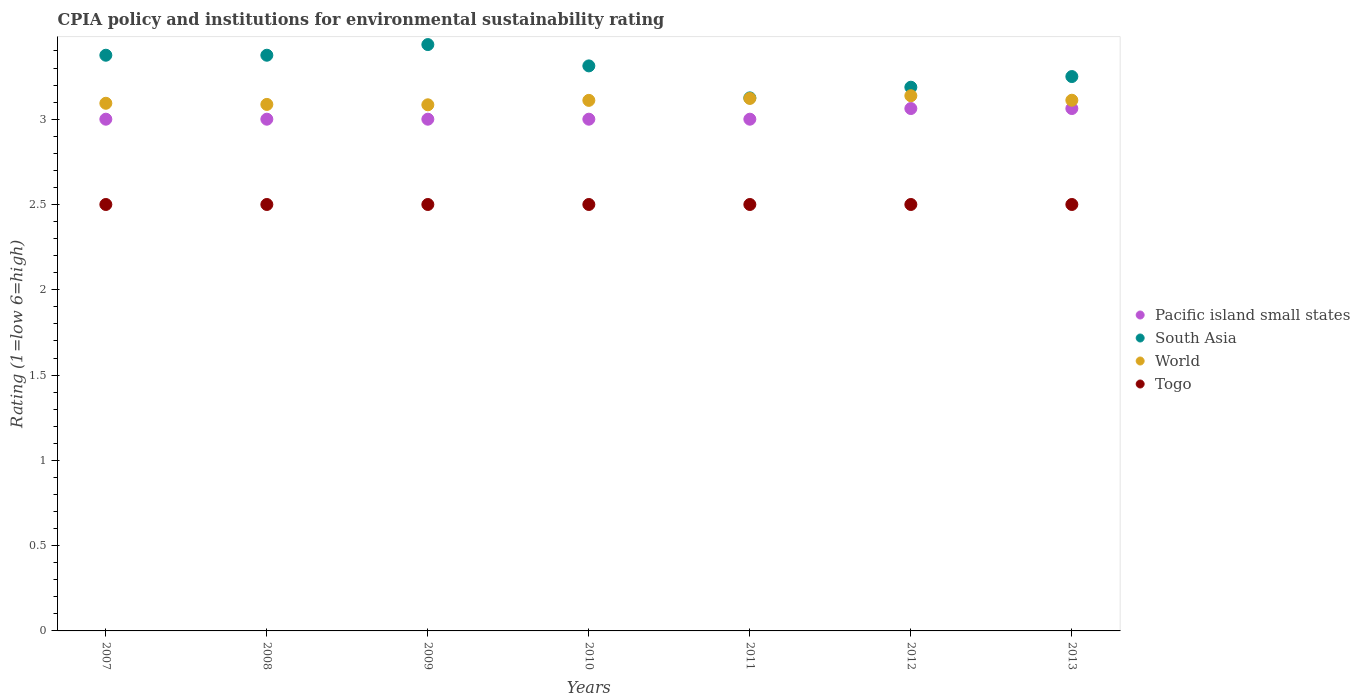What is the CPIA rating in Pacific island small states in 2007?
Ensure brevity in your answer.  3. Across all years, what is the maximum CPIA rating in World?
Offer a terse response. 3.14. Across all years, what is the minimum CPIA rating in South Asia?
Your response must be concise. 3.12. In which year was the CPIA rating in Togo minimum?
Keep it short and to the point. 2007. What is the total CPIA rating in Pacific island small states in the graph?
Keep it short and to the point. 21.12. What is the difference between the CPIA rating in World in 2008 and that in 2009?
Your answer should be very brief. 0. What is the difference between the CPIA rating in Pacific island small states in 2011 and the CPIA rating in South Asia in 2012?
Your answer should be compact. -0.19. What is the average CPIA rating in World per year?
Provide a short and direct response. 3.11. In the year 2010, what is the difference between the CPIA rating in South Asia and CPIA rating in World?
Make the answer very short. 0.2. In how many years, is the CPIA rating in World greater than 1.4?
Your answer should be very brief. 7. What is the ratio of the CPIA rating in Togo in 2007 to that in 2008?
Your answer should be very brief. 1. Is the CPIA rating in Pacific island small states in 2011 less than that in 2013?
Give a very brief answer. Yes. Is the difference between the CPIA rating in South Asia in 2010 and 2013 greater than the difference between the CPIA rating in World in 2010 and 2013?
Your response must be concise. Yes. What is the difference between the highest and the second highest CPIA rating in Togo?
Ensure brevity in your answer.  0. In how many years, is the CPIA rating in Togo greater than the average CPIA rating in Togo taken over all years?
Offer a very short reply. 0. Is the sum of the CPIA rating in South Asia in 2007 and 2008 greater than the maximum CPIA rating in Togo across all years?
Ensure brevity in your answer.  Yes. Is it the case that in every year, the sum of the CPIA rating in World and CPIA rating in Togo  is greater than the CPIA rating in South Asia?
Your answer should be compact. Yes. Is the CPIA rating in South Asia strictly greater than the CPIA rating in Pacific island small states over the years?
Provide a short and direct response. Yes. How many years are there in the graph?
Provide a short and direct response. 7. Does the graph contain any zero values?
Provide a short and direct response. No. Does the graph contain grids?
Offer a terse response. No. Where does the legend appear in the graph?
Make the answer very short. Center right. How many legend labels are there?
Provide a short and direct response. 4. How are the legend labels stacked?
Make the answer very short. Vertical. What is the title of the graph?
Provide a short and direct response. CPIA policy and institutions for environmental sustainability rating. Does "Malaysia" appear as one of the legend labels in the graph?
Provide a short and direct response. No. What is the label or title of the Y-axis?
Offer a terse response. Rating (1=low 6=high). What is the Rating (1=low 6=high) in Pacific island small states in 2007?
Ensure brevity in your answer.  3. What is the Rating (1=low 6=high) of South Asia in 2007?
Keep it short and to the point. 3.38. What is the Rating (1=low 6=high) in World in 2007?
Give a very brief answer. 3.09. What is the Rating (1=low 6=high) of Togo in 2007?
Offer a very short reply. 2.5. What is the Rating (1=low 6=high) in South Asia in 2008?
Ensure brevity in your answer.  3.38. What is the Rating (1=low 6=high) in World in 2008?
Provide a short and direct response. 3.09. What is the Rating (1=low 6=high) in Togo in 2008?
Provide a short and direct response. 2.5. What is the Rating (1=low 6=high) of Pacific island small states in 2009?
Your answer should be compact. 3. What is the Rating (1=low 6=high) in South Asia in 2009?
Your answer should be very brief. 3.44. What is the Rating (1=low 6=high) of World in 2009?
Offer a terse response. 3.08. What is the Rating (1=low 6=high) of Pacific island small states in 2010?
Offer a terse response. 3. What is the Rating (1=low 6=high) in South Asia in 2010?
Offer a terse response. 3.31. What is the Rating (1=low 6=high) in World in 2010?
Ensure brevity in your answer.  3.11. What is the Rating (1=low 6=high) in South Asia in 2011?
Offer a very short reply. 3.12. What is the Rating (1=low 6=high) of World in 2011?
Provide a short and direct response. 3.12. What is the Rating (1=low 6=high) of Pacific island small states in 2012?
Offer a terse response. 3.06. What is the Rating (1=low 6=high) of South Asia in 2012?
Your response must be concise. 3.19. What is the Rating (1=low 6=high) in World in 2012?
Offer a terse response. 3.14. What is the Rating (1=low 6=high) in Togo in 2012?
Your answer should be compact. 2.5. What is the Rating (1=low 6=high) of Pacific island small states in 2013?
Offer a very short reply. 3.06. What is the Rating (1=low 6=high) in South Asia in 2013?
Offer a terse response. 3.25. What is the Rating (1=low 6=high) in World in 2013?
Make the answer very short. 3.11. Across all years, what is the maximum Rating (1=low 6=high) in Pacific island small states?
Provide a succinct answer. 3.06. Across all years, what is the maximum Rating (1=low 6=high) in South Asia?
Give a very brief answer. 3.44. Across all years, what is the maximum Rating (1=low 6=high) of World?
Make the answer very short. 3.14. Across all years, what is the minimum Rating (1=low 6=high) of Pacific island small states?
Offer a terse response. 3. Across all years, what is the minimum Rating (1=low 6=high) in South Asia?
Offer a very short reply. 3.12. Across all years, what is the minimum Rating (1=low 6=high) in World?
Keep it short and to the point. 3.08. What is the total Rating (1=low 6=high) in Pacific island small states in the graph?
Give a very brief answer. 21.12. What is the total Rating (1=low 6=high) in South Asia in the graph?
Offer a terse response. 23.06. What is the total Rating (1=low 6=high) of World in the graph?
Ensure brevity in your answer.  21.75. What is the difference between the Rating (1=low 6=high) in Pacific island small states in 2007 and that in 2008?
Offer a terse response. 0. What is the difference between the Rating (1=low 6=high) of South Asia in 2007 and that in 2008?
Ensure brevity in your answer.  0. What is the difference between the Rating (1=low 6=high) in World in 2007 and that in 2008?
Offer a terse response. 0.01. What is the difference between the Rating (1=low 6=high) of South Asia in 2007 and that in 2009?
Give a very brief answer. -0.06. What is the difference between the Rating (1=low 6=high) in World in 2007 and that in 2009?
Your response must be concise. 0.01. What is the difference between the Rating (1=low 6=high) in Togo in 2007 and that in 2009?
Provide a short and direct response. 0. What is the difference between the Rating (1=low 6=high) of Pacific island small states in 2007 and that in 2010?
Provide a short and direct response. 0. What is the difference between the Rating (1=low 6=high) in South Asia in 2007 and that in 2010?
Give a very brief answer. 0.06. What is the difference between the Rating (1=low 6=high) of World in 2007 and that in 2010?
Your answer should be very brief. -0.02. What is the difference between the Rating (1=low 6=high) of Pacific island small states in 2007 and that in 2011?
Ensure brevity in your answer.  0. What is the difference between the Rating (1=low 6=high) in South Asia in 2007 and that in 2011?
Provide a short and direct response. 0.25. What is the difference between the Rating (1=low 6=high) in World in 2007 and that in 2011?
Provide a succinct answer. -0.03. What is the difference between the Rating (1=low 6=high) of Togo in 2007 and that in 2011?
Keep it short and to the point. 0. What is the difference between the Rating (1=low 6=high) of Pacific island small states in 2007 and that in 2012?
Provide a short and direct response. -0.06. What is the difference between the Rating (1=low 6=high) of South Asia in 2007 and that in 2012?
Your answer should be compact. 0.19. What is the difference between the Rating (1=low 6=high) in World in 2007 and that in 2012?
Your answer should be very brief. -0.04. What is the difference between the Rating (1=low 6=high) in Togo in 2007 and that in 2012?
Your response must be concise. 0. What is the difference between the Rating (1=low 6=high) in Pacific island small states in 2007 and that in 2013?
Offer a very short reply. -0.06. What is the difference between the Rating (1=low 6=high) of South Asia in 2007 and that in 2013?
Your answer should be compact. 0.12. What is the difference between the Rating (1=low 6=high) of World in 2007 and that in 2013?
Provide a succinct answer. -0.02. What is the difference between the Rating (1=low 6=high) in Togo in 2007 and that in 2013?
Your answer should be compact. 0. What is the difference between the Rating (1=low 6=high) of Pacific island small states in 2008 and that in 2009?
Ensure brevity in your answer.  0. What is the difference between the Rating (1=low 6=high) in South Asia in 2008 and that in 2009?
Keep it short and to the point. -0.06. What is the difference between the Rating (1=low 6=high) of World in 2008 and that in 2009?
Offer a terse response. 0. What is the difference between the Rating (1=low 6=high) of Togo in 2008 and that in 2009?
Offer a very short reply. 0. What is the difference between the Rating (1=low 6=high) of Pacific island small states in 2008 and that in 2010?
Provide a succinct answer. 0. What is the difference between the Rating (1=low 6=high) of South Asia in 2008 and that in 2010?
Ensure brevity in your answer.  0.06. What is the difference between the Rating (1=low 6=high) of World in 2008 and that in 2010?
Your answer should be very brief. -0.02. What is the difference between the Rating (1=low 6=high) of World in 2008 and that in 2011?
Provide a succinct answer. -0.04. What is the difference between the Rating (1=low 6=high) of Pacific island small states in 2008 and that in 2012?
Give a very brief answer. -0.06. What is the difference between the Rating (1=low 6=high) of South Asia in 2008 and that in 2012?
Your answer should be very brief. 0.19. What is the difference between the Rating (1=low 6=high) of World in 2008 and that in 2012?
Offer a terse response. -0.05. What is the difference between the Rating (1=low 6=high) in Pacific island small states in 2008 and that in 2013?
Offer a very short reply. -0.06. What is the difference between the Rating (1=low 6=high) in World in 2008 and that in 2013?
Provide a succinct answer. -0.02. What is the difference between the Rating (1=low 6=high) in World in 2009 and that in 2010?
Your answer should be very brief. -0.03. What is the difference between the Rating (1=low 6=high) in Pacific island small states in 2009 and that in 2011?
Your answer should be very brief. 0. What is the difference between the Rating (1=low 6=high) in South Asia in 2009 and that in 2011?
Provide a short and direct response. 0.31. What is the difference between the Rating (1=low 6=high) in World in 2009 and that in 2011?
Your answer should be very brief. -0.04. What is the difference between the Rating (1=low 6=high) in Togo in 2009 and that in 2011?
Your response must be concise. 0. What is the difference between the Rating (1=low 6=high) of Pacific island small states in 2009 and that in 2012?
Offer a very short reply. -0.06. What is the difference between the Rating (1=low 6=high) of World in 2009 and that in 2012?
Offer a very short reply. -0.05. What is the difference between the Rating (1=low 6=high) of Togo in 2009 and that in 2012?
Your response must be concise. 0. What is the difference between the Rating (1=low 6=high) of Pacific island small states in 2009 and that in 2013?
Keep it short and to the point. -0.06. What is the difference between the Rating (1=low 6=high) of South Asia in 2009 and that in 2013?
Your answer should be compact. 0.19. What is the difference between the Rating (1=low 6=high) in World in 2009 and that in 2013?
Give a very brief answer. -0.03. What is the difference between the Rating (1=low 6=high) of South Asia in 2010 and that in 2011?
Offer a terse response. 0.19. What is the difference between the Rating (1=low 6=high) of World in 2010 and that in 2011?
Offer a very short reply. -0.01. What is the difference between the Rating (1=low 6=high) in Pacific island small states in 2010 and that in 2012?
Give a very brief answer. -0.06. What is the difference between the Rating (1=low 6=high) of World in 2010 and that in 2012?
Your answer should be compact. -0.03. What is the difference between the Rating (1=low 6=high) in Pacific island small states in 2010 and that in 2013?
Provide a succinct answer. -0.06. What is the difference between the Rating (1=low 6=high) of South Asia in 2010 and that in 2013?
Keep it short and to the point. 0.06. What is the difference between the Rating (1=low 6=high) of World in 2010 and that in 2013?
Provide a short and direct response. -0. What is the difference between the Rating (1=low 6=high) of Pacific island small states in 2011 and that in 2012?
Keep it short and to the point. -0.06. What is the difference between the Rating (1=low 6=high) of South Asia in 2011 and that in 2012?
Offer a terse response. -0.06. What is the difference between the Rating (1=low 6=high) of World in 2011 and that in 2012?
Offer a very short reply. -0.02. What is the difference between the Rating (1=low 6=high) of Pacific island small states in 2011 and that in 2013?
Ensure brevity in your answer.  -0.06. What is the difference between the Rating (1=low 6=high) in South Asia in 2011 and that in 2013?
Provide a short and direct response. -0.12. What is the difference between the Rating (1=low 6=high) in World in 2011 and that in 2013?
Provide a succinct answer. 0.01. What is the difference between the Rating (1=low 6=high) in Togo in 2011 and that in 2013?
Ensure brevity in your answer.  0. What is the difference between the Rating (1=low 6=high) of Pacific island small states in 2012 and that in 2013?
Provide a short and direct response. 0. What is the difference between the Rating (1=low 6=high) of South Asia in 2012 and that in 2013?
Give a very brief answer. -0.06. What is the difference between the Rating (1=low 6=high) of World in 2012 and that in 2013?
Your answer should be very brief. 0.03. What is the difference between the Rating (1=low 6=high) of Pacific island small states in 2007 and the Rating (1=low 6=high) of South Asia in 2008?
Keep it short and to the point. -0.38. What is the difference between the Rating (1=low 6=high) of Pacific island small states in 2007 and the Rating (1=low 6=high) of World in 2008?
Your answer should be compact. -0.09. What is the difference between the Rating (1=low 6=high) of South Asia in 2007 and the Rating (1=low 6=high) of World in 2008?
Ensure brevity in your answer.  0.29. What is the difference between the Rating (1=low 6=high) in South Asia in 2007 and the Rating (1=low 6=high) in Togo in 2008?
Give a very brief answer. 0.88. What is the difference between the Rating (1=low 6=high) in World in 2007 and the Rating (1=low 6=high) in Togo in 2008?
Offer a very short reply. 0.59. What is the difference between the Rating (1=low 6=high) in Pacific island small states in 2007 and the Rating (1=low 6=high) in South Asia in 2009?
Your response must be concise. -0.44. What is the difference between the Rating (1=low 6=high) of Pacific island small states in 2007 and the Rating (1=low 6=high) of World in 2009?
Ensure brevity in your answer.  -0.08. What is the difference between the Rating (1=low 6=high) in South Asia in 2007 and the Rating (1=low 6=high) in World in 2009?
Provide a short and direct response. 0.29. What is the difference between the Rating (1=low 6=high) of South Asia in 2007 and the Rating (1=low 6=high) of Togo in 2009?
Keep it short and to the point. 0.88. What is the difference between the Rating (1=low 6=high) in World in 2007 and the Rating (1=low 6=high) in Togo in 2009?
Keep it short and to the point. 0.59. What is the difference between the Rating (1=low 6=high) of Pacific island small states in 2007 and the Rating (1=low 6=high) of South Asia in 2010?
Offer a very short reply. -0.31. What is the difference between the Rating (1=low 6=high) in Pacific island small states in 2007 and the Rating (1=low 6=high) in World in 2010?
Your answer should be very brief. -0.11. What is the difference between the Rating (1=low 6=high) of South Asia in 2007 and the Rating (1=low 6=high) of World in 2010?
Your response must be concise. 0.26. What is the difference between the Rating (1=low 6=high) of South Asia in 2007 and the Rating (1=low 6=high) of Togo in 2010?
Provide a short and direct response. 0.88. What is the difference between the Rating (1=low 6=high) of World in 2007 and the Rating (1=low 6=high) of Togo in 2010?
Ensure brevity in your answer.  0.59. What is the difference between the Rating (1=low 6=high) in Pacific island small states in 2007 and the Rating (1=low 6=high) in South Asia in 2011?
Provide a short and direct response. -0.12. What is the difference between the Rating (1=low 6=high) of Pacific island small states in 2007 and the Rating (1=low 6=high) of World in 2011?
Your answer should be very brief. -0.12. What is the difference between the Rating (1=low 6=high) in Pacific island small states in 2007 and the Rating (1=low 6=high) in Togo in 2011?
Provide a succinct answer. 0.5. What is the difference between the Rating (1=low 6=high) of South Asia in 2007 and the Rating (1=low 6=high) of World in 2011?
Ensure brevity in your answer.  0.25. What is the difference between the Rating (1=low 6=high) in World in 2007 and the Rating (1=low 6=high) in Togo in 2011?
Your answer should be very brief. 0.59. What is the difference between the Rating (1=low 6=high) of Pacific island small states in 2007 and the Rating (1=low 6=high) of South Asia in 2012?
Your response must be concise. -0.19. What is the difference between the Rating (1=low 6=high) in Pacific island small states in 2007 and the Rating (1=low 6=high) in World in 2012?
Provide a short and direct response. -0.14. What is the difference between the Rating (1=low 6=high) in Pacific island small states in 2007 and the Rating (1=low 6=high) in Togo in 2012?
Give a very brief answer. 0.5. What is the difference between the Rating (1=low 6=high) in South Asia in 2007 and the Rating (1=low 6=high) in World in 2012?
Offer a very short reply. 0.24. What is the difference between the Rating (1=low 6=high) of World in 2007 and the Rating (1=low 6=high) of Togo in 2012?
Your response must be concise. 0.59. What is the difference between the Rating (1=low 6=high) in Pacific island small states in 2007 and the Rating (1=low 6=high) in South Asia in 2013?
Your answer should be very brief. -0.25. What is the difference between the Rating (1=low 6=high) in Pacific island small states in 2007 and the Rating (1=low 6=high) in World in 2013?
Make the answer very short. -0.11. What is the difference between the Rating (1=low 6=high) of South Asia in 2007 and the Rating (1=low 6=high) of World in 2013?
Provide a short and direct response. 0.26. What is the difference between the Rating (1=low 6=high) of World in 2007 and the Rating (1=low 6=high) of Togo in 2013?
Make the answer very short. 0.59. What is the difference between the Rating (1=low 6=high) in Pacific island small states in 2008 and the Rating (1=low 6=high) in South Asia in 2009?
Ensure brevity in your answer.  -0.44. What is the difference between the Rating (1=low 6=high) in Pacific island small states in 2008 and the Rating (1=low 6=high) in World in 2009?
Your answer should be very brief. -0.08. What is the difference between the Rating (1=low 6=high) of South Asia in 2008 and the Rating (1=low 6=high) of World in 2009?
Offer a terse response. 0.29. What is the difference between the Rating (1=low 6=high) in South Asia in 2008 and the Rating (1=low 6=high) in Togo in 2009?
Provide a short and direct response. 0.88. What is the difference between the Rating (1=low 6=high) in World in 2008 and the Rating (1=low 6=high) in Togo in 2009?
Keep it short and to the point. 0.59. What is the difference between the Rating (1=low 6=high) of Pacific island small states in 2008 and the Rating (1=low 6=high) of South Asia in 2010?
Provide a succinct answer. -0.31. What is the difference between the Rating (1=low 6=high) in Pacific island small states in 2008 and the Rating (1=low 6=high) in World in 2010?
Ensure brevity in your answer.  -0.11. What is the difference between the Rating (1=low 6=high) of South Asia in 2008 and the Rating (1=low 6=high) of World in 2010?
Your answer should be very brief. 0.26. What is the difference between the Rating (1=low 6=high) of South Asia in 2008 and the Rating (1=low 6=high) of Togo in 2010?
Your response must be concise. 0.88. What is the difference between the Rating (1=low 6=high) in World in 2008 and the Rating (1=low 6=high) in Togo in 2010?
Your response must be concise. 0.59. What is the difference between the Rating (1=low 6=high) of Pacific island small states in 2008 and the Rating (1=low 6=high) of South Asia in 2011?
Your response must be concise. -0.12. What is the difference between the Rating (1=low 6=high) in Pacific island small states in 2008 and the Rating (1=low 6=high) in World in 2011?
Provide a short and direct response. -0.12. What is the difference between the Rating (1=low 6=high) of Pacific island small states in 2008 and the Rating (1=low 6=high) of Togo in 2011?
Offer a very short reply. 0.5. What is the difference between the Rating (1=low 6=high) of South Asia in 2008 and the Rating (1=low 6=high) of World in 2011?
Offer a very short reply. 0.25. What is the difference between the Rating (1=low 6=high) in World in 2008 and the Rating (1=low 6=high) in Togo in 2011?
Your answer should be compact. 0.59. What is the difference between the Rating (1=low 6=high) in Pacific island small states in 2008 and the Rating (1=low 6=high) in South Asia in 2012?
Your answer should be very brief. -0.19. What is the difference between the Rating (1=low 6=high) in Pacific island small states in 2008 and the Rating (1=low 6=high) in World in 2012?
Your answer should be very brief. -0.14. What is the difference between the Rating (1=low 6=high) in South Asia in 2008 and the Rating (1=low 6=high) in World in 2012?
Provide a succinct answer. 0.24. What is the difference between the Rating (1=low 6=high) in South Asia in 2008 and the Rating (1=low 6=high) in Togo in 2012?
Ensure brevity in your answer.  0.88. What is the difference between the Rating (1=low 6=high) of World in 2008 and the Rating (1=low 6=high) of Togo in 2012?
Provide a succinct answer. 0.59. What is the difference between the Rating (1=low 6=high) of Pacific island small states in 2008 and the Rating (1=low 6=high) of South Asia in 2013?
Offer a terse response. -0.25. What is the difference between the Rating (1=low 6=high) in Pacific island small states in 2008 and the Rating (1=low 6=high) in World in 2013?
Your response must be concise. -0.11. What is the difference between the Rating (1=low 6=high) in Pacific island small states in 2008 and the Rating (1=low 6=high) in Togo in 2013?
Make the answer very short. 0.5. What is the difference between the Rating (1=low 6=high) of South Asia in 2008 and the Rating (1=low 6=high) of World in 2013?
Provide a short and direct response. 0.26. What is the difference between the Rating (1=low 6=high) in South Asia in 2008 and the Rating (1=low 6=high) in Togo in 2013?
Provide a short and direct response. 0.88. What is the difference between the Rating (1=low 6=high) of World in 2008 and the Rating (1=low 6=high) of Togo in 2013?
Ensure brevity in your answer.  0.59. What is the difference between the Rating (1=low 6=high) of Pacific island small states in 2009 and the Rating (1=low 6=high) of South Asia in 2010?
Your response must be concise. -0.31. What is the difference between the Rating (1=low 6=high) of Pacific island small states in 2009 and the Rating (1=low 6=high) of World in 2010?
Keep it short and to the point. -0.11. What is the difference between the Rating (1=low 6=high) of Pacific island small states in 2009 and the Rating (1=low 6=high) of Togo in 2010?
Your response must be concise. 0.5. What is the difference between the Rating (1=low 6=high) of South Asia in 2009 and the Rating (1=low 6=high) of World in 2010?
Provide a short and direct response. 0.33. What is the difference between the Rating (1=low 6=high) in South Asia in 2009 and the Rating (1=low 6=high) in Togo in 2010?
Give a very brief answer. 0.94. What is the difference between the Rating (1=low 6=high) in World in 2009 and the Rating (1=low 6=high) in Togo in 2010?
Offer a terse response. 0.58. What is the difference between the Rating (1=low 6=high) of Pacific island small states in 2009 and the Rating (1=low 6=high) of South Asia in 2011?
Give a very brief answer. -0.12. What is the difference between the Rating (1=low 6=high) of Pacific island small states in 2009 and the Rating (1=low 6=high) of World in 2011?
Your answer should be compact. -0.12. What is the difference between the Rating (1=low 6=high) in South Asia in 2009 and the Rating (1=low 6=high) in World in 2011?
Your answer should be very brief. 0.32. What is the difference between the Rating (1=low 6=high) of World in 2009 and the Rating (1=low 6=high) of Togo in 2011?
Offer a very short reply. 0.58. What is the difference between the Rating (1=low 6=high) in Pacific island small states in 2009 and the Rating (1=low 6=high) in South Asia in 2012?
Offer a very short reply. -0.19. What is the difference between the Rating (1=low 6=high) in Pacific island small states in 2009 and the Rating (1=low 6=high) in World in 2012?
Offer a terse response. -0.14. What is the difference between the Rating (1=low 6=high) in South Asia in 2009 and the Rating (1=low 6=high) in World in 2012?
Your answer should be very brief. 0.3. What is the difference between the Rating (1=low 6=high) of World in 2009 and the Rating (1=low 6=high) of Togo in 2012?
Your answer should be compact. 0.58. What is the difference between the Rating (1=low 6=high) of Pacific island small states in 2009 and the Rating (1=low 6=high) of South Asia in 2013?
Ensure brevity in your answer.  -0.25. What is the difference between the Rating (1=low 6=high) in Pacific island small states in 2009 and the Rating (1=low 6=high) in World in 2013?
Ensure brevity in your answer.  -0.11. What is the difference between the Rating (1=low 6=high) in Pacific island small states in 2009 and the Rating (1=low 6=high) in Togo in 2013?
Offer a very short reply. 0.5. What is the difference between the Rating (1=low 6=high) of South Asia in 2009 and the Rating (1=low 6=high) of World in 2013?
Make the answer very short. 0.33. What is the difference between the Rating (1=low 6=high) in World in 2009 and the Rating (1=low 6=high) in Togo in 2013?
Keep it short and to the point. 0.58. What is the difference between the Rating (1=low 6=high) in Pacific island small states in 2010 and the Rating (1=low 6=high) in South Asia in 2011?
Your answer should be compact. -0.12. What is the difference between the Rating (1=low 6=high) in Pacific island small states in 2010 and the Rating (1=low 6=high) in World in 2011?
Your response must be concise. -0.12. What is the difference between the Rating (1=low 6=high) in South Asia in 2010 and the Rating (1=low 6=high) in World in 2011?
Your answer should be compact. 0.19. What is the difference between the Rating (1=low 6=high) in South Asia in 2010 and the Rating (1=low 6=high) in Togo in 2011?
Ensure brevity in your answer.  0.81. What is the difference between the Rating (1=low 6=high) of World in 2010 and the Rating (1=low 6=high) of Togo in 2011?
Your response must be concise. 0.61. What is the difference between the Rating (1=low 6=high) in Pacific island small states in 2010 and the Rating (1=low 6=high) in South Asia in 2012?
Give a very brief answer. -0.19. What is the difference between the Rating (1=low 6=high) in Pacific island small states in 2010 and the Rating (1=low 6=high) in World in 2012?
Your answer should be very brief. -0.14. What is the difference between the Rating (1=low 6=high) in Pacific island small states in 2010 and the Rating (1=low 6=high) in Togo in 2012?
Make the answer very short. 0.5. What is the difference between the Rating (1=low 6=high) in South Asia in 2010 and the Rating (1=low 6=high) in World in 2012?
Provide a short and direct response. 0.17. What is the difference between the Rating (1=low 6=high) in South Asia in 2010 and the Rating (1=low 6=high) in Togo in 2012?
Ensure brevity in your answer.  0.81. What is the difference between the Rating (1=low 6=high) of World in 2010 and the Rating (1=low 6=high) of Togo in 2012?
Offer a very short reply. 0.61. What is the difference between the Rating (1=low 6=high) in Pacific island small states in 2010 and the Rating (1=low 6=high) in South Asia in 2013?
Offer a terse response. -0.25. What is the difference between the Rating (1=low 6=high) of Pacific island small states in 2010 and the Rating (1=low 6=high) of World in 2013?
Give a very brief answer. -0.11. What is the difference between the Rating (1=low 6=high) in Pacific island small states in 2010 and the Rating (1=low 6=high) in Togo in 2013?
Your response must be concise. 0.5. What is the difference between the Rating (1=low 6=high) in South Asia in 2010 and the Rating (1=low 6=high) in World in 2013?
Give a very brief answer. 0.2. What is the difference between the Rating (1=low 6=high) of South Asia in 2010 and the Rating (1=low 6=high) of Togo in 2013?
Make the answer very short. 0.81. What is the difference between the Rating (1=low 6=high) of World in 2010 and the Rating (1=low 6=high) of Togo in 2013?
Make the answer very short. 0.61. What is the difference between the Rating (1=low 6=high) of Pacific island small states in 2011 and the Rating (1=low 6=high) of South Asia in 2012?
Ensure brevity in your answer.  -0.19. What is the difference between the Rating (1=low 6=high) in Pacific island small states in 2011 and the Rating (1=low 6=high) in World in 2012?
Offer a terse response. -0.14. What is the difference between the Rating (1=low 6=high) in Pacific island small states in 2011 and the Rating (1=low 6=high) in Togo in 2012?
Make the answer very short. 0.5. What is the difference between the Rating (1=low 6=high) in South Asia in 2011 and the Rating (1=low 6=high) in World in 2012?
Your answer should be compact. -0.01. What is the difference between the Rating (1=low 6=high) of World in 2011 and the Rating (1=low 6=high) of Togo in 2012?
Offer a very short reply. 0.62. What is the difference between the Rating (1=low 6=high) in Pacific island small states in 2011 and the Rating (1=low 6=high) in World in 2013?
Your answer should be compact. -0.11. What is the difference between the Rating (1=low 6=high) of South Asia in 2011 and the Rating (1=low 6=high) of World in 2013?
Make the answer very short. 0.01. What is the difference between the Rating (1=low 6=high) of World in 2011 and the Rating (1=low 6=high) of Togo in 2013?
Ensure brevity in your answer.  0.62. What is the difference between the Rating (1=low 6=high) of Pacific island small states in 2012 and the Rating (1=low 6=high) of South Asia in 2013?
Your answer should be very brief. -0.19. What is the difference between the Rating (1=low 6=high) in Pacific island small states in 2012 and the Rating (1=low 6=high) in World in 2013?
Provide a short and direct response. -0.05. What is the difference between the Rating (1=low 6=high) of Pacific island small states in 2012 and the Rating (1=low 6=high) of Togo in 2013?
Offer a very short reply. 0.56. What is the difference between the Rating (1=low 6=high) of South Asia in 2012 and the Rating (1=low 6=high) of World in 2013?
Keep it short and to the point. 0.08. What is the difference between the Rating (1=low 6=high) of South Asia in 2012 and the Rating (1=low 6=high) of Togo in 2013?
Your response must be concise. 0.69. What is the difference between the Rating (1=low 6=high) in World in 2012 and the Rating (1=low 6=high) in Togo in 2013?
Your response must be concise. 0.64. What is the average Rating (1=low 6=high) of Pacific island small states per year?
Keep it short and to the point. 3.02. What is the average Rating (1=low 6=high) of South Asia per year?
Your answer should be very brief. 3.29. What is the average Rating (1=low 6=high) of World per year?
Offer a very short reply. 3.11. In the year 2007, what is the difference between the Rating (1=low 6=high) of Pacific island small states and Rating (1=low 6=high) of South Asia?
Give a very brief answer. -0.38. In the year 2007, what is the difference between the Rating (1=low 6=high) of Pacific island small states and Rating (1=low 6=high) of World?
Provide a succinct answer. -0.09. In the year 2007, what is the difference between the Rating (1=low 6=high) of Pacific island small states and Rating (1=low 6=high) of Togo?
Provide a succinct answer. 0.5. In the year 2007, what is the difference between the Rating (1=low 6=high) of South Asia and Rating (1=low 6=high) of World?
Provide a succinct answer. 0.28. In the year 2007, what is the difference between the Rating (1=low 6=high) of South Asia and Rating (1=low 6=high) of Togo?
Provide a short and direct response. 0.88. In the year 2007, what is the difference between the Rating (1=low 6=high) of World and Rating (1=low 6=high) of Togo?
Provide a succinct answer. 0.59. In the year 2008, what is the difference between the Rating (1=low 6=high) in Pacific island small states and Rating (1=low 6=high) in South Asia?
Ensure brevity in your answer.  -0.38. In the year 2008, what is the difference between the Rating (1=low 6=high) of Pacific island small states and Rating (1=low 6=high) of World?
Your response must be concise. -0.09. In the year 2008, what is the difference between the Rating (1=low 6=high) in South Asia and Rating (1=low 6=high) in World?
Ensure brevity in your answer.  0.29. In the year 2008, what is the difference between the Rating (1=low 6=high) of World and Rating (1=low 6=high) of Togo?
Provide a short and direct response. 0.59. In the year 2009, what is the difference between the Rating (1=low 6=high) of Pacific island small states and Rating (1=low 6=high) of South Asia?
Your answer should be compact. -0.44. In the year 2009, what is the difference between the Rating (1=low 6=high) of Pacific island small states and Rating (1=low 6=high) of World?
Provide a short and direct response. -0.08. In the year 2009, what is the difference between the Rating (1=low 6=high) in Pacific island small states and Rating (1=low 6=high) in Togo?
Provide a succinct answer. 0.5. In the year 2009, what is the difference between the Rating (1=low 6=high) of South Asia and Rating (1=low 6=high) of World?
Provide a short and direct response. 0.35. In the year 2009, what is the difference between the Rating (1=low 6=high) of South Asia and Rating (1=low 6=high) of Togo?
Make the answer very short. 0.94. In the year 2009, what is the difference between the Rating (1=low 6=high) in World and Rating (1=low 6=high) in Togo?
Make the answer very short. 0.58. In the year 2010, what is the difference between the Rating (1=low 6=high) in Pacific island small states and Rating (1=low 6=high) in South Asia?
Your response must be concise. -0.31. In the year 2010, what is the difference between the Rating (1=low 6=high) in Pacific island small states and Rating (1=low 6=high) in World?
Provide a short and direct response. -0.11. In the year 2010, what is the difference between the Rating (1=low 6=high) of South Asia and Rating (1=low 6=high) of World?
Offer a very short reply. 0.2. In the year 2010, what is the difference between the Rating (1=low 6=high) of South Asia and Rating (1=low 6=high) of Togo?
Provide a short and direct response. 0.81. In the year 2010, what is the difference between the Rating (1=low 6=high) in World and Rating (1=low 6=high) in Togo?
Ensure brevity in your answer.  0.61. In the year 2011, what is the difference between the Rating (1=low 6=high) in Pacific island small states and Rating (1=low 6=high) in South Asia?
Your answer should be compact. -0.12. In the year 2011, what is the difference between the Rating (1=low 6=high) in Pacific island small states and Rating (1=low 6=high) in World?
Give a very brief answer. -0.12. In the year 2011, what is the difference between the Rating (1=low 6=high) of Pacific island small states and Rating (1=low 6=high) of Togo?
Your response must be concise. 0.5. In the year 2011, what is the difference between the Rating (1=low 6=high) in South Asia and Rating (1=low 6=high) in World?
Keep it short and to the point. 0. In the year 2011, what is the difference between the Rating (1=low 6=high) in South Asia and Rating (1=low 6=high) in Togo?
Your response must be concise. 0.62. In the year 2011, what is the difference between the Rating (1=low 6=high) in World and Rating (1=low 6=high) in Togo?
Offer a very short reply. 0.62. In the year 2012, what is the difference between the Rating (1=low 6=high) of Pacific island small states and Rating (1=low 6=high) of South Asia?
Offer a very short reply. -0.12. In the year 2012, what is the difference between the Rating (1=low 6=high) in Pacific island small states and Rating (1=low 6=high) in World?
Your response must be concise. -0.07. In the year 2012, what is the difference between the Rating (1=low 6=high) of Pacific island small states and Rating (1=low 6=high) of Togo?
Provide a succinct answer. 0.56. In the year 2012, what is the difference between the Rating (1=low 6=high) of South Asia and Rating (1=low 6=high) of World?
Provide a short and direct response. 0.05. In the year 2012, what is the difference between the Rating (1=low 6=high) in South Asia and Rating (1=low 6=high) in Togo?
Provide a short and direct response. 0.69. In the year 2012, what is the difference between the Rating (1=low 6=high) in World and Rating (1=low 6=high) in Togo?
Give a very brief answer. 0.64. In the year 2013, what is the difference between the Rating (1=low 6=high) of Pacific island small states and Rating (1=low 6=high) of South Asia?
Keep it short and to the point. -0.19. In the year 2013, what is the difference between the Rating (1=low 6=high) of Pacific island small states and Rating (1=low 6=high) of World?
Keep it short and to the point. -0.05. In the year 2013, what is the difference between the Rating (1=low 6=high) of Pacific island small states and Rating (1=low 6=high) of Togo?
Offer a terse response. 0.56. In the year 2013, what is the difference between the Rating (1=low 6=high) in South Asia and Rating (1=low 6=high) in World?
Offer a terse response. 0.14. In the year 2013, what is the difference between the Rating (1=low 6=high) of World and Rating (1=low 6=high) of Togo?
Keep it short and to the point. 0.61. What is the ratio of the Rating (1=low 6=high) in Pacific island small states in 2007 to that in 2008?
Offer a very short reply. 1. What is the ratio of the Rating (1=low 6=high) of South Asia in 2007 to that in 2008?
Make the answer very short. 1. What is the ratio of the Rating (1=low 6=high) in World in 2007 to that in 2008?
Offer a terse response. 1. What is the ratio of the Rating (1=low 6=high) of South Asia in 2007 to that in 2009?
Your response must be concise. 0.98. What is the ratio of the Rating (1=low 6=high) in World in 2007 to that in 2009?
Provide a short and direct response. 1. What is the ratio of the Rating (1=low 6=high) in South Asia in 2007 to that in 2010?
Provide a short and direct response. 1.02. What is the ratio of the Rating (1=low 6=high) in Togo in 2007 to that in 2010?
Your response must be concise. 1. What is the ratio of the Rating (1=low 6=high) of Pacific island small states in 2007 to that in 2011?
Your response must be concise. 1. What is the ratio of the Rating (1=low 6=high) in South Asia in 2007 to that in 2011?
Provide a succinct answer. 1.08. What is the ratio of the Rating (1=low 6=high) in World in 2007 to that in 2011?
Your answer should be very brief. 0.99. What is the ratio of the Rating (1=low 6=high) of Togo in 2007 to that in 2011?
Offer a terse response. 1. What is the ratio of the Rating (1=low 6=high) of Pacific island small states in 2007 to that in 2012?
Give a very brief answer. 0.98. What is the ratio of the Rating (1=low 6=high) of South Asia in 2007 to that in 2012?
Provide a short and direct response. 1.06. What is the ratio of the Rating (1=low 6=high) in World in 2007 to that in 2012?
Provide a succinct answer. 0.99. What is the ratio of the Rating (1=low 6=high) of Togo in 2007 to that in 2012?
Keep it short and to the point. 1. What is the ratio of the Rating (1=low 6=high) in Pacific island small states in 2007 to that in 2013?
Your response must be concise. 0.98. What is the ratio of the Rating (1=low 6=high) in World in 2007 to that in 2013?
Offer a very short reply. 0.99. What is the ratio of the Rating (1=low 6=high) in Togo in 2007 to that in 2013?
Offer a terse response. 1. What is the ratio of the Rating (1=low 6=high) of Pacific island small states in 2008 to that in 2009?
Ensure brevity in your answer.  1. What is the ratio of the Rating (1=low 6=high) of South Asia in 2008 to that in 2009?
Give a very brief answer. 0.98. What is the ratio of the Rating (1=low 6=high) in World in 2008 to that in 2009?
Ensure brevity in your answer.  1. What is the ratio of the Rating (1=low 6=high) in South Asia in 2008 to that in 2010?
Your answer should be compact. 1.02. What is the ratio of the Rating (1=low 6=high) of Togo in 2008 to that in 2010?
Your response must be concise. 1. What is the ratio of the Rating (1=low 6=high) of South Asia in 2008 to that in 2011?
Provide a short and direct response. 1.08. What is the ratio of the Rating (1=low 6=high) of World in 2008 to that in 2011?
Give a very brief answer. 0.99. What is the ratio of the Rating (1=low 6=high) in Togo in 2008 to that in 2011?
Your answer should be compact. 1. What is the ratio of the Rating (1=low 6=high) in Pacific island small states in 2008 to that in 2012?
Your answer should be compact. 0.98. What is the ratio of the Rating (1=low 6=high) of South Asia in 2008 to that in 2012?
Provide a short and direct response. 1.06. What is the ratio of the Rating (1=low 6=high) in World in 2008 to that in 2012?
Your response must be concise. 0.98. What is the ratio of the Rating (1=low 6=high) in Togo in 2008 to that in 2012?
Offer a very short reply. 1. What is the ratio of the Rating (1=low 6=high) of Pacific island small states in 2008 to that in 2013?
Provide a short and direct response. 0.98. What is the ratio of the Rating (1=low 6=high) of South Asia in 2008 to that in 2013?
Make the answer very short. 1.04. What is the ratio of the Rating (1=low 6=high) of Togo in 2008 to that in 2013?
Your answer should be compact. 1. What is the ratio of the Rating (1=low 6=high) of Pacific island small states in 2009 to that in 2010?
Your response must be concise. 1. What is the ratio of the Rating (1=low 6=high) in South Asia in 2009 to that in 2010?
Provide a succinct answer. 1.04. What is the ratio of the Rating (1=low 6=high) of World in 2009 to that in 2010?
Provide a succinct answer. 0.99. What is the ratio of the Rating (1=low 6=high) in Togo in 2009 to that in 2010?
Keep it short and to the point. 1. What is the ratio of the Rating (1=low 6=high) in Pacific island small states in 2009 to that in 2011?
Your answer should be very brief. 1. What is the ratio of the Rating (1=low 6=high) in Pacific island small states in 2009 to that in 2012?
Offer a terse response. 0.98. What is the ratio of the Rating (1=low 6=high) of South Asia in 2009 to that in 2012?
Ensure brevity in your answer.  1.08. What is the ratio of the Rating (1=low 6=high) in World in 2009 to that in 2012?
Provide a succinct answer. 0.98. What is the ratio of the Rating (1=low 6=high) in Pacific island small states in 2009 to that in 2013?
Give a very brief answer. 0.98. What is the ratio of the Rating (1=low 6=high) of South Asia in 2009 to that in 2013?
Provide a succinct answer. 1.06. What is the ratio of the Rating (1=low 6=high) of Togo in 2009 to that in 2013?
Your answer should be very brief. 1. What is the ratio of the Rating (1=low 6=high) in South Asia in 2010 to that in 2011?
Make the answer very short. 1.06. What is the ratio of the Rating (1=low 6=high) in Togo in 2010 to that in 2011?
Offer a very short reply. 1. What is the ratio of the Rating (1=low 6=high) in Pacific island small states in 2010 to that in 2012?
Your answer should be compact. 0.98. What is the ratio of the Rating (1=low 6=high) of South Asia in 2010 to that in 2012?
Offer a terse response. 1.04. What is the ratio of the Rating (1=low 6=high) of World in 2010 to that in 2012?
Ensure brevity in your answer.  0.99. What is the ratio of the Rating (1=low 6=high) of Pacific island small states in 2010 to that in 2013?
Your answer should be very brief. 0.98. What is the ratio of the Rating (1=low 6=high) of South Asia in 2010 to that in 2013?
Offer a very short reply. 1.02. What is the ratio of the Rating (1=low 6=high) of World in 2010 to that in 2013?
Keep it short and to the point. 1. What is the ratio of the Rating (1=low 6=high) of Togo in 2010 to that in 2013?
Keep it short and to the point. 1. What is the ratio of the Rating (1=low 6=high) of Pacific island small states in 2011 to that in 2012?
Provide a succinct answer. 0.98. What is the ratio of the Rating (1=low 6=high) in South Asia in 2011 to that in 2012?
Provide a short and direct response. 0.98. What is the ratio of the Rating (1=low 6=high) in World in 2011 to that in 2012?
Ensure brevity in your answer.  0.99. What is the ratio of the Rating (1=low 6=high) in Pacific island small states in 2011 to that in 2013?
Give a very brief answer. 0.98. What is the ratio of the Rating (1=low 6=high) of South Asia in 2011 to that in 2013?
Provide a succinct answer. 0.96. What is the ratio of the Rating (1=low 6=high) of World in 2011 to that in 2013?
Offer a very short reply. 1. What is the ratio of the Rating (1=low 6=high) of Togo in 2011 to that in 2013?
Keep it short and to the point. 1. What is the ratio of the Rating (1=low 6=high) of Pacific island small states in 2012 to that in 2013?
Provide a succinct answer. 1. What is the ratio of the Rating (1=low 6=high) in South Asia in 2012 to that in 2013?
Ensure brevity in your answer.  0.98. What is the ratio of the Rating (1=low 6=high) in World in 2012 to that in 2013?
Offer a very short reply. 1.01. What is the ratio of the Rating (1=low 6=high) of Togo in 2012 to that in 2013?
Give a very brief answer. 1. What is the difference between the highest and the second highest Rating (1=low 6=high) of Pacific island small states?
Ensure brevity in your answer.  0. What is the difference between the highest and the second highest Rating (1=low 6=high) in South Asia?
Your answer should be compact. 0.06. What is the difference between the highest and the second highest Rating (1=low 6=high) in World?
Offer a terse response. 0.02. What is the difference between the highest and the lowest Rating (1=low 6=high) in Pacific island small states?
Provide a short and direct response. 0.06. What is the difference between the highest and the lowest Rating (1=low 6=high) of South Asia?
Make the answer very short. 0.31. What is the difference between the highest and the lowest Rating (1=low 6=high) of World?
Offer a very short reply. 0.05. 